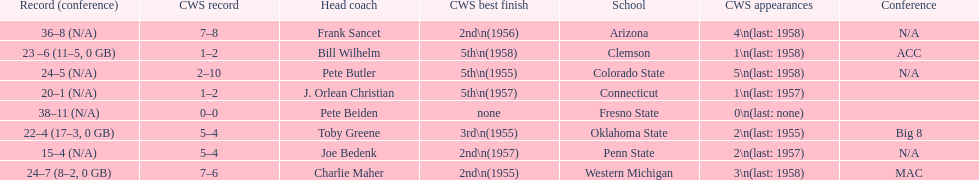List the schools that came in last place in the cws best finish. Clemson, Colorado State, Connecticut. 